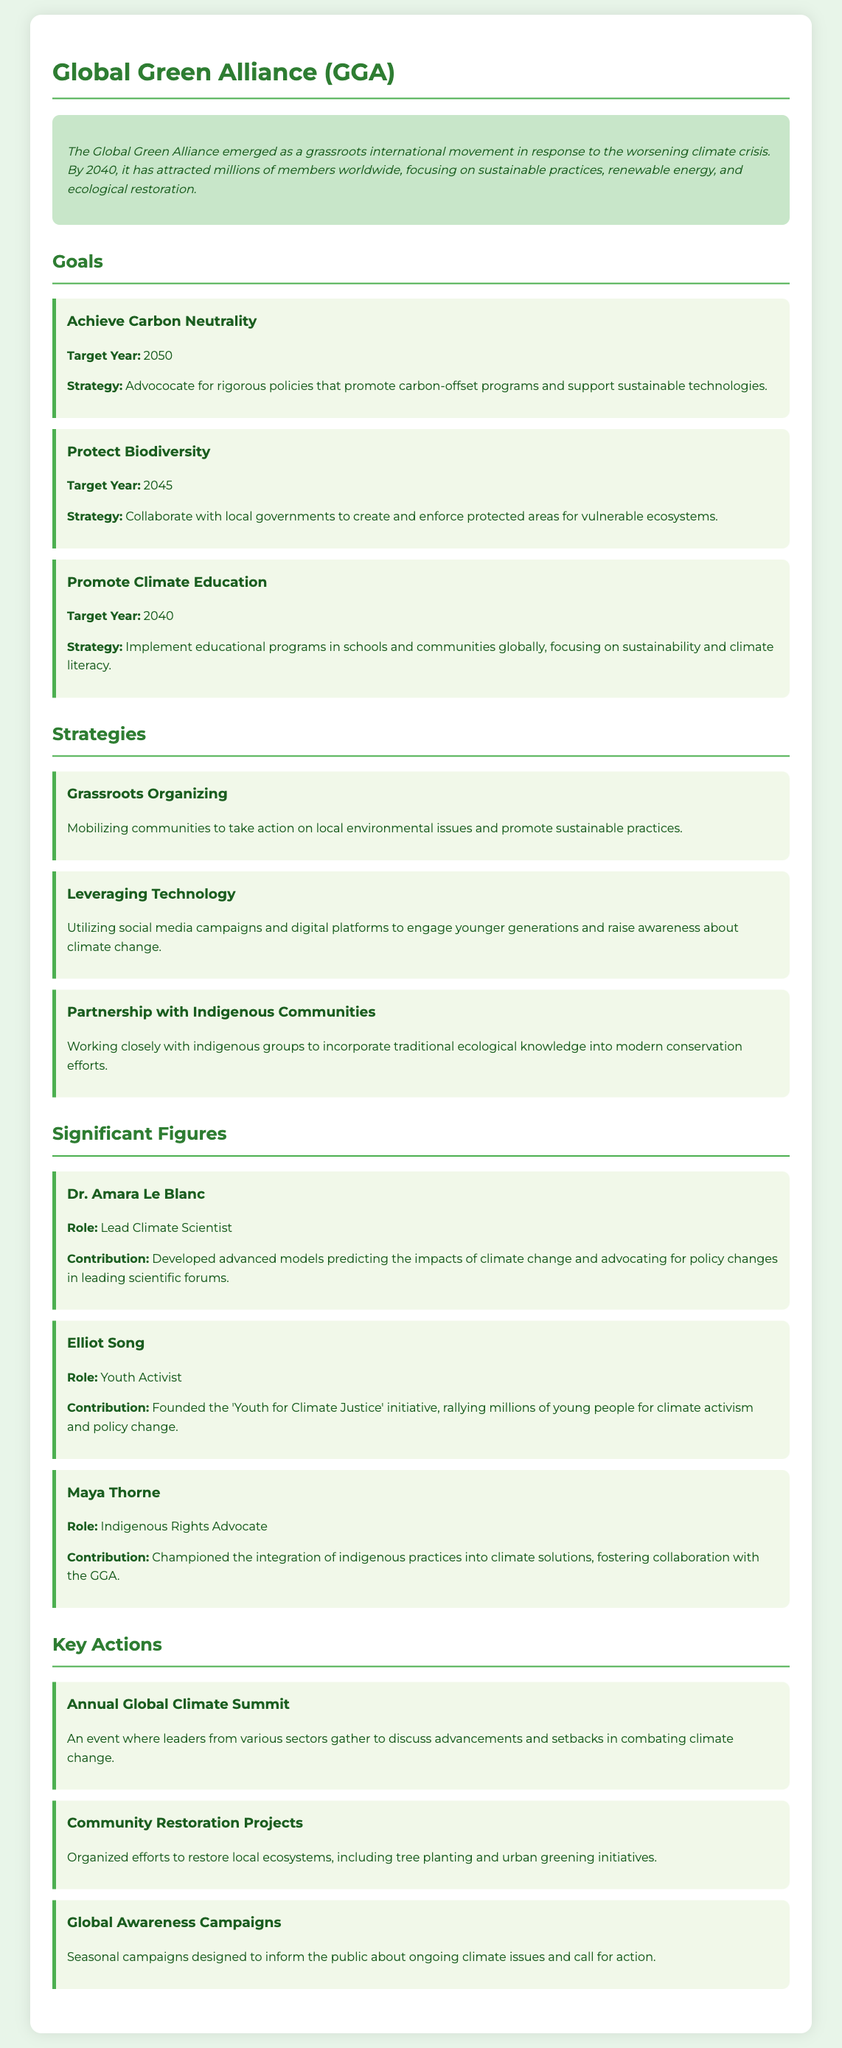What is the name of the climate movement? The name of the climate movement is mentioned at the top of the document.
Answer: Global Green Alliance What is the target year for achieving carbon neutrality? The target year is provided as part of the goal for carbon neutrality.
Answer: 2050 Who is the Lead Climate Scientist mentioned in the document? The document lists significant figures along with their roles and contributions.
Answer: Dr. Amara Le Blanc What is the strategy for promoting climate education? The document details the strategies associated with each goal.
Answer: Implement educational programs in schools and communities globally What is one significant action the Global Green Alliance organizes annually? The document lists key actions of the movement, including events.
Answer: Annual Global Climate Summit Which year is the goal for protecting biodiversity set for? The target year for protecting biodiversity is specified under its goal.
Answer: 2045 What type of organizing is emphasized in the movement's strategies? The strategies section outlines various methods for mobilization.
Answer: Grassroots Organizing Who founded the 'Youth for Climate Justice' initiative? This information is found in the section on significant figures.
Answer: Elliot Song 